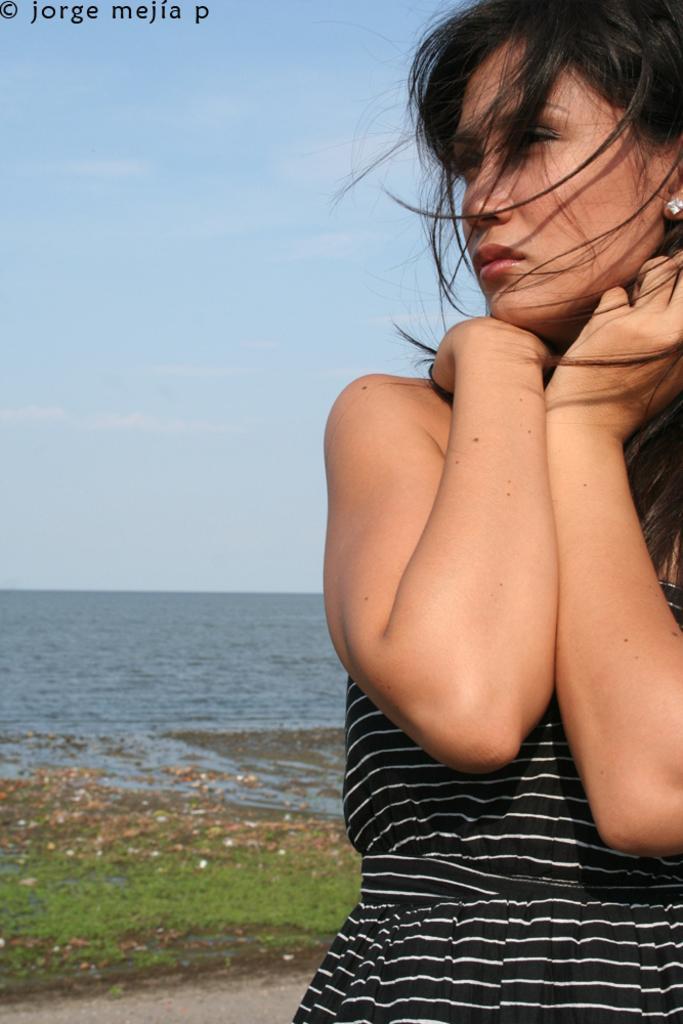How would you summarize this image in a sentence or two? In front of the image there is a person. Behind her there is grass and dried leaves on the surface. In the background of the image there is water. At the top of the image there is sky. There is some text at the top of the image. 